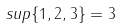Convert formula to latex. <formula><loc_0><loc_0><loc_500><loc_500>s u p \{ 1 , 2 , 3 \} = 3</formula> 